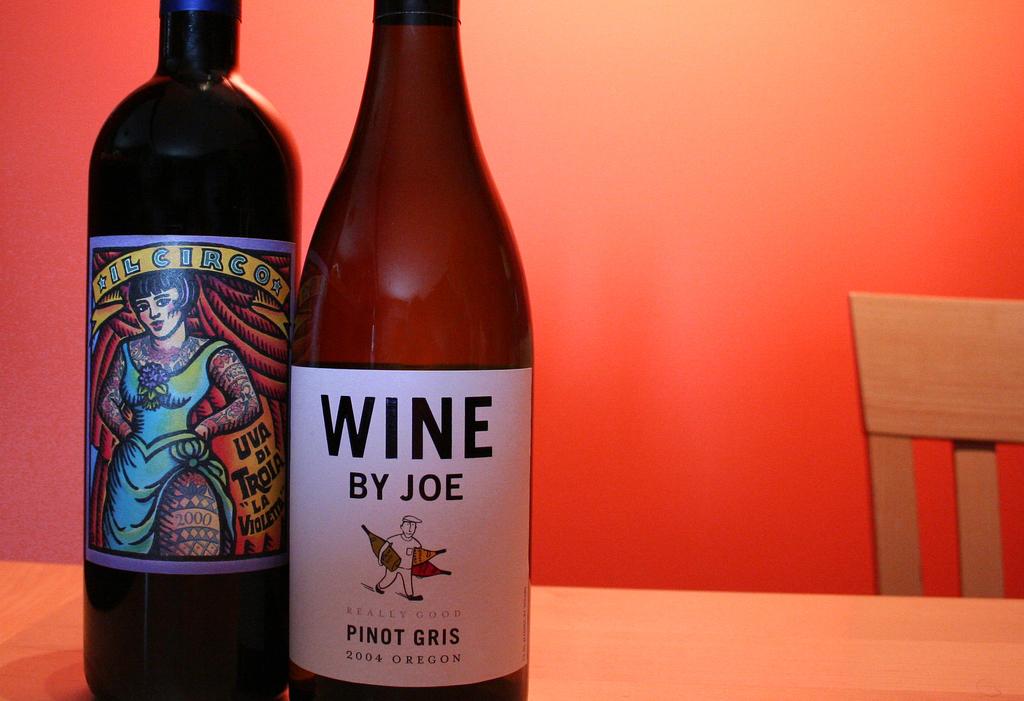Who is the wine by?
Your answer should be very brief. Joe. What year did joe make this wine?
Ensure brevity in your answer.  2004. 